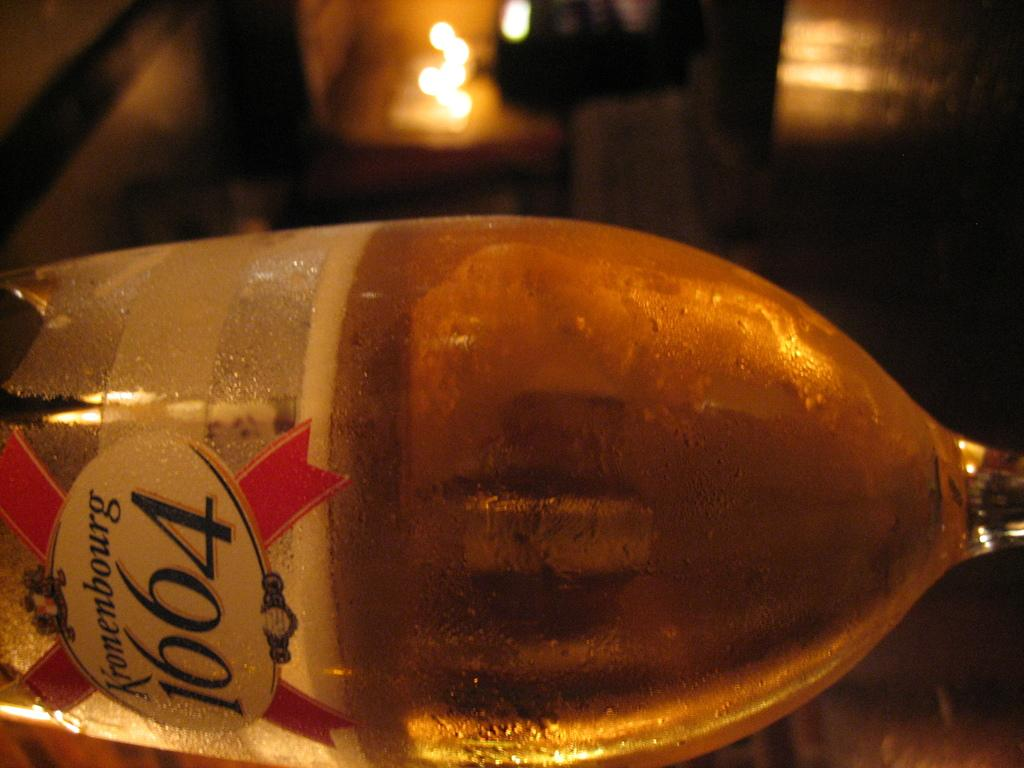Provide a one-sentence caption for the provided image. A Bottle of Kronenbourg 1664 lying on the table. 